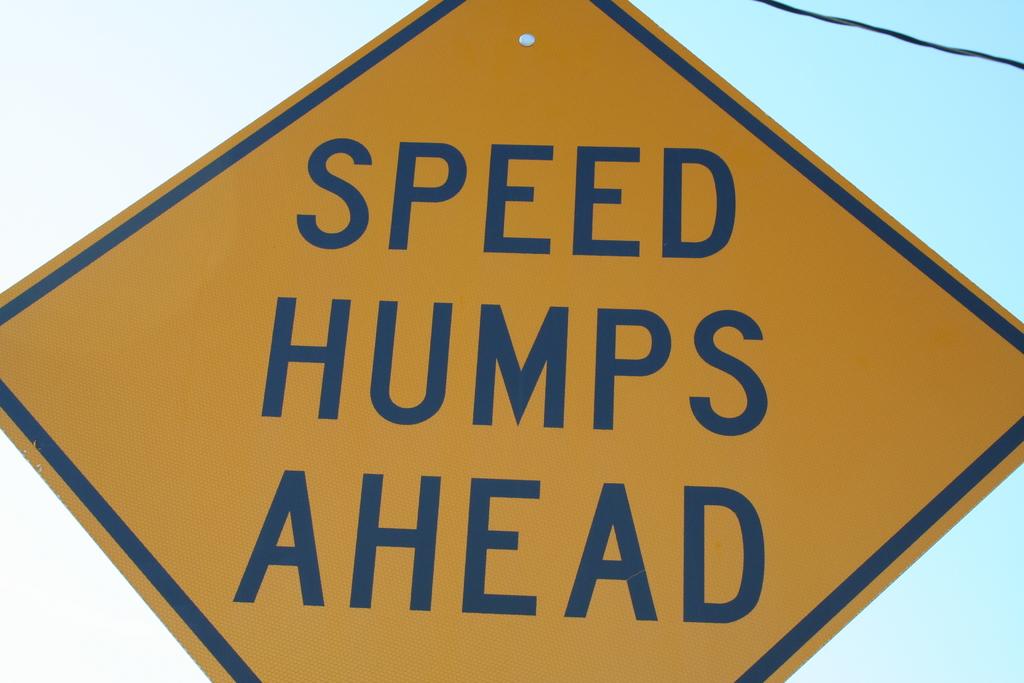What is coming up on the road?
Your answer should be compact. Speed humps. Where are the speed humps?
Give a very brief answer. Ahead. 